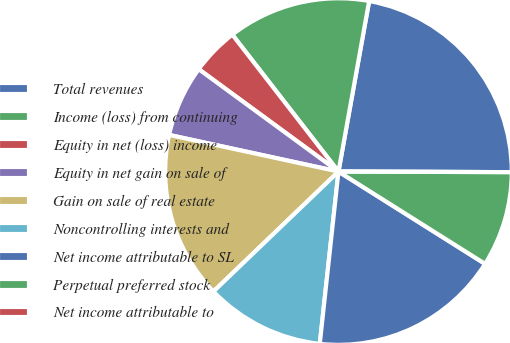<chart> <loc_0><loc_0><loc_500><loc_500><pie_chart><fcel>Total revenues<fcel>Income (loss) from continuing<fcel>Equity in net (loss) income<fcel>Equity in net gain on sale of<fcel>Gain on sale of real estate<fcel>Noncontrolling interests and<fcel>Net income attributable to SL<fcel>Perpetual preferred stock<fcel>Net income attributable to<nl><fcel>22.22%<fcel>13.33%<fcel>4.44%<fcel>6.67%<fcel>15.56%<fcel>11.11%<fcel>17.78%<fcel>8.89%<fcel>0.0%<nl></chart> 